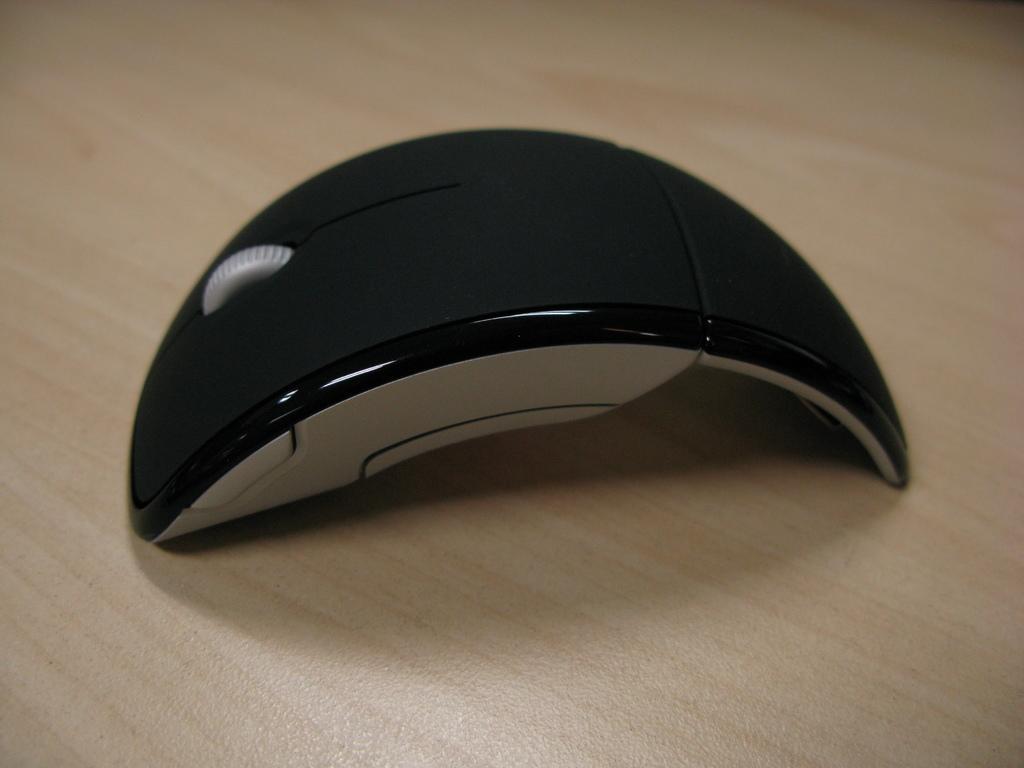Please provide a concise description of this image. In this image we can see a mouse on the wooden surface. 